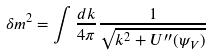<formula> <loc_0><loc_0><loc_500><loc_500>\delta m ^ { 2 } = \int \frac { d k } { 4 \pi } \frac { 1 } { \sqrt { k ^ { 2 } + U ^ { \prime \prime } ( \psi _ { V } ) } }</formula> 